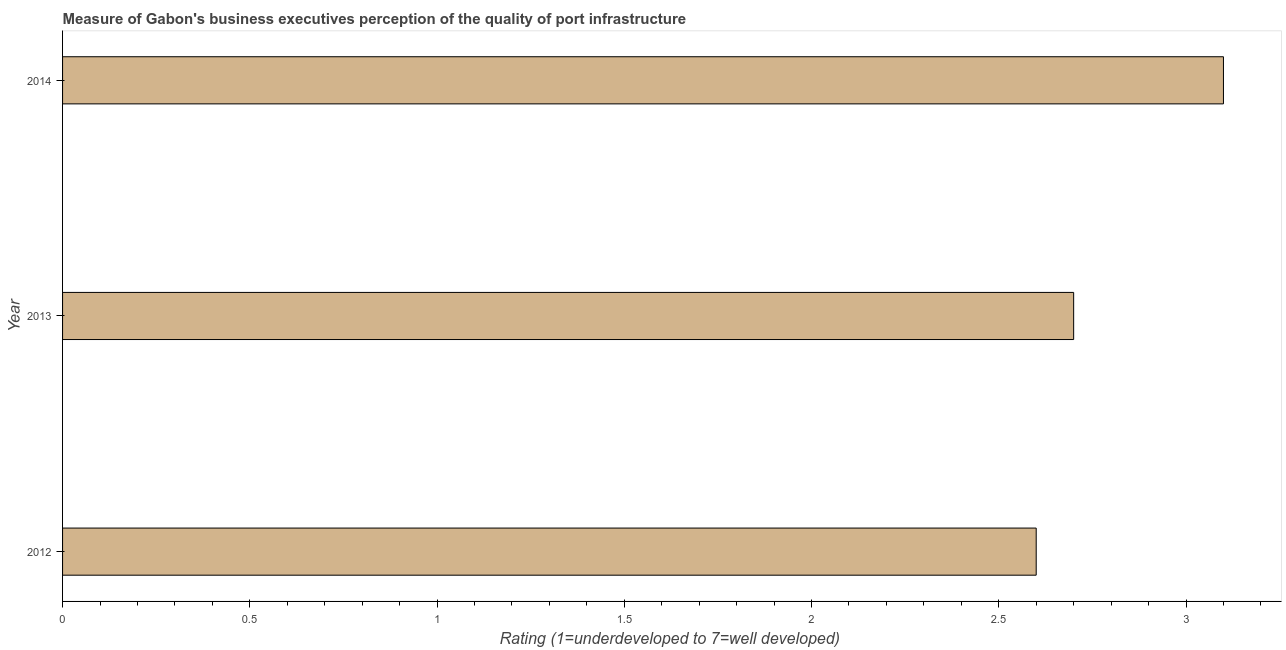What is the title of the graph?
Provide a short and direct response. Measure of Gabon's business executives perception of the quality of port infrastructure. What is the label or title of the X-axis?
Make the answer very short. Rating (1=underdeveloped to 7=well developed) . What is the label or title of the Y-axis?
Your answer should be compact. Year. Across all years, what is the maximum rating measuring quality of port infrastructure?
Your response must be concise. 3.1. Across all years, what is the minimum rating measuring quality of port infrastructure?
Make the answer very short. 2.6. In which year was the rating measuring quality of port infrastructure maximum?
Offer a terse response. 2014. What is the sum of the rating measuring quality of port infrastructure?
Ensure brevity in your answer.  8.4. What is the median rating measuring quality of port infrastructure?
Keep it short and to the point. 2.7. Do a majority of the years between 2013 and 2012 (inclusive) have rating measuring quality of port infrastructure greater than 2.7 ?
Your answer should be compact. No. What is the ratio of the rating measuring quality of port infrastructure in 2012 to that in 2014?
Keep it short and to the point. 0.84. Is the rating measuring quality of port infrastructure in 2012 less than that in 2013?
Your response must be concise. Yes. Is the difference between the rating measuring quality of port infrastructure in 2012 and 2013 greater than the difference between any two years?
Keep it short and to the point. No. What is the difference between the highest and the second highest rating measuring quality of port infrastructure?
Provide a short and direct response. 0.4. Is the sum of the rating measuring quality of port infrastructure in 2013 and 2014 greater than the maximum rating measuring quality of port infrastructure across all years?
Provide a short and direct response. Yes. What is the difference between the highest and the lowest rating measuring quality of port infrastructure?
Your answer should be compact. 0.5. Are all the bars in the graph horizontal?
Your response must be concise. Yes. What is the difference between two consecutive major ticks on the X-axis?
Offer a terse response. 0.5. What is the Rating (1=underdeveloped to 7=well developed)  in 2012?
Your response must be concise. 2.6. What is the Rating (1=underdeveloped to 7=well developed)  of 2013?
Ensure brevity in your answer.  2.7. What is the difference between the Rating (1=underdeveloped to 7=well developed)  in 2012 and 2013?
Provide a succinct answer. -0.1. What is the difference between the Rating (1=underdeveloped to 7=well developed)  in 2012 and 2014?
Give a very brief answer. -0.5. What is the difference between the Rating (1=underdeveloped to 7=well developed)  in 2013 and 2014?
Your answer should be compact. -0.4. What is the ratio of the Rating (1=underdeveloped to 7=well developed)  in 2012 to that in 2014?
Your answer should be very brief. 0.84. What is the ratio of the Rating (1=underdeveloped to 7=well developed)  in 2013 to that in 2014?
Keep it short and to the point. 0.87. 